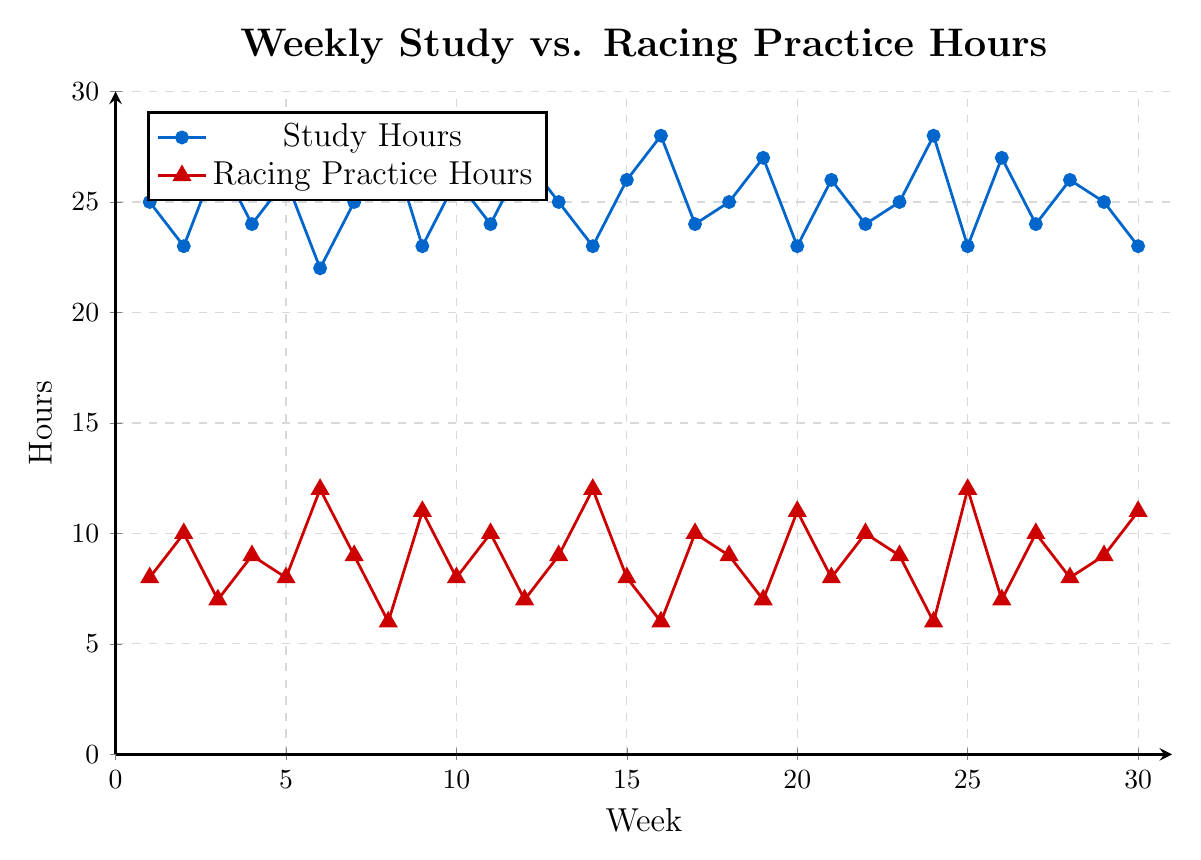What is the general trend in study hours throughout the school year? The trend in study hours fluctuates somewhat but generally ranges between 22 to 28 hours each week. The hours rise and fall periodically without a clear increasing or decreasing trend.
Answer: Fluctuating Which week has the maximum study hours and how many hours was it? To find the maximum study hours, check the highest value on the study hours line. The maximum is 28 hours. This occurs multiple times, such as in weeks 8, 16, and 24.
Answer: 28 hours at weeks 8, 16, and 24 How many weeks had exactly 25 study hours? To determine the number of weeks with exactly 25 study hours, count the number of points at 25 on the study hours line. These points are at weeks 1, 7, 13, 18, and 29. So, there are 5 occurrences.
Answer: 5 weeks When study hours are 28, what are the corresponding racing practice hours? Locate the weeks where study hours are 28, which are weeks 8, 16, and 24. At those weeks, the racing practice hours are 6 hours each.
Answer: 6 hours What is the difference between the highest and lowest racing practice hours recorded in the figure? The highest racing practice hours are 12, which occurs multiple times, such as in weeks 6, 14, and 25. The lowest racing practice hours are 6, occurring in weeks 8, 16, and 24. The difference is 12 - 6 = 6 hours.
Answer: 6 hours Identify the weeks where both study and racing practice hours are neither at their highest nor lowest values. Study hours range from 22 to 28, and racing practice hours range from 6 to 12. The highest and lowest values are excluded for both sets. Valid weeks are the ones with study hours = 23, 24, 25, 26, and 27, and racing hours = 7, 8, 9, 10, and 11. Cross-referencing these:
- Study=23, Racing=10 (week 2),
- Study=24, Racing=10 (week 11, 22, 27),
- Study=25, Racing=9 (week 13, 18, 29). So, the results are weeks 2, 11, 13, 18, 22, 27, and 29.
Answer: Weeks 2, 11, 13, 18, 22, 27, 29 What is the average number of racing practice hours over the first 10 weeks? Add up the racing practice hours for weeks 1 to 10, which are 8 + 10 + 7 + 9 + 8 + 12 + 9 + 6 + 11 + 8 = 88. There are 10 weeks, so the average is 88 / 10 = 8.8 hours.
Answer: 8.8 hours Which weeks have a racing practice hour exactly double that of study hours? No weeks meet this criterion because the maximum study hours is 28, meaning the highest double could be 56, which is far outside the 12-hour max for racing practice.
Answer: None 